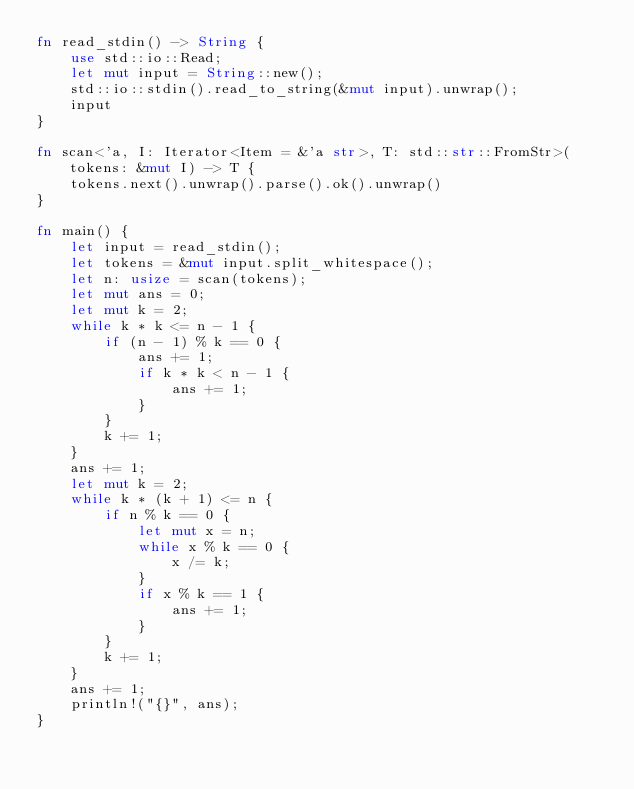<code> <loc_0><loc_0><loc_500><loc_500><_Rust_>fn read_stdin() -> String {
    use std::io::Read;
    let mut input = String::new();
    std::io::stdin().read_to_string(&mut input).unwrap();
    input
}

fn scan<'a, I: Iterator<Item = &'a str>, T: std::str::FromStr>(tokens: &mut I) -> T {
    tokens.next().unwrap().parse().ok().unwrap()
}

fn main() {
    let input = read_stdin();
    let tokens = &mut input.split_whitespace();
    let n: usize = scan(tokens);
    let mut ans = 0;
    let mut k = 2;
    while k * k <= n - 1 {
        if (n - 1) % k == 0 {
            ans += 1;
            if k * k < n - 1 {
                ans += 1;
            }
        }
        k += 1;
    }
    ans += 1;
    let mut k = 2;
    while k * (k + 1) <= n {
        if n % k == 0 {
            let mut x = n;
            while x % k == 0 {
                x /= k;
            }
            if x % k == 1 {
                ans += 1;
            }
        }
        k += 1;
    }
    ans += 1;
    println!("{}", ans);
}
</code> 